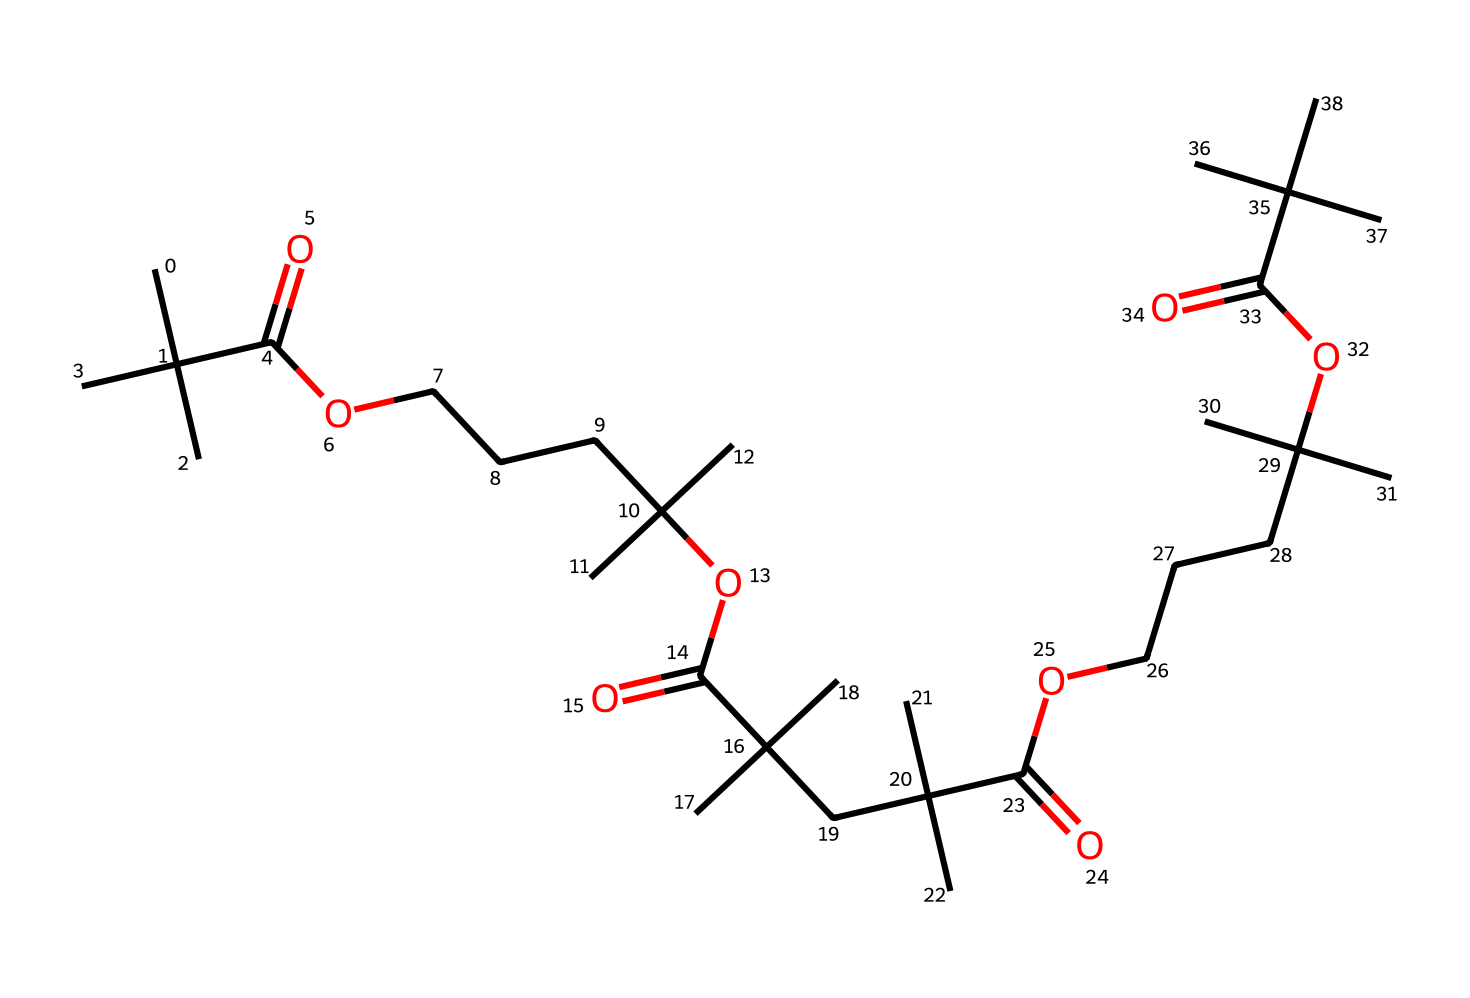How many carbon atoms are in the structure? By examining the SMILES representation, we count the number of carbon (C) atoms. Each 'C' represents one carbon atom. The parentheses indicate branching, but every carbon atom in the linear and branched structures is accounted for. A careful count reveals there are a total of 27 carbon atoms.
Answer: 27 What type of chemical structure does this represent? The presence of carbon chains and ester functional groups (indicated by 'C(=O)O') throughout the structure suggests that this chemical represents a polymer, specifically one that might be used in noise-cancelling acoustic foams. Polymers are large molecules composed of repeated subunits.
Answer: polymer How many ester groups are present? The structure has distinct 'C(=O)O' segments, each corresponding to an ester group. Counting these groups within the SMILES representation indicates that there are 4 ester groups.
Answer: 4 What is the primary intended use of this polymer? The chemical structure, characterized by its acoustic foam properties (lightweight, sound-absorbing), indicates that this polymer is specifically designed for noise-cancellation. The arrangement and composition favor sound insulation, making it suitable for applications in audio equipment.
Answer: noise-cancellation Is this polymer hydrophobic or hydrophilic? The long hydrocarbon chains indicate a predominance of carbon and hydrogen, which typically results in hydrophobic properties. Given the structure, it can be reasoned that the polymer is hydrophobic, as it resists water absorption.
Answer: hydrophobic Does this structure indicate branching, and if so, where? In the SMILES notation, branches can be identified by the use of parentheses; for example, 'C(C)(C)' shows branching as groups are attached to a central carbon. The analysis reveals multiple branched sections throughout the polymer, specifically at various carbon atoms.
Answer: Yes, branching occurs 